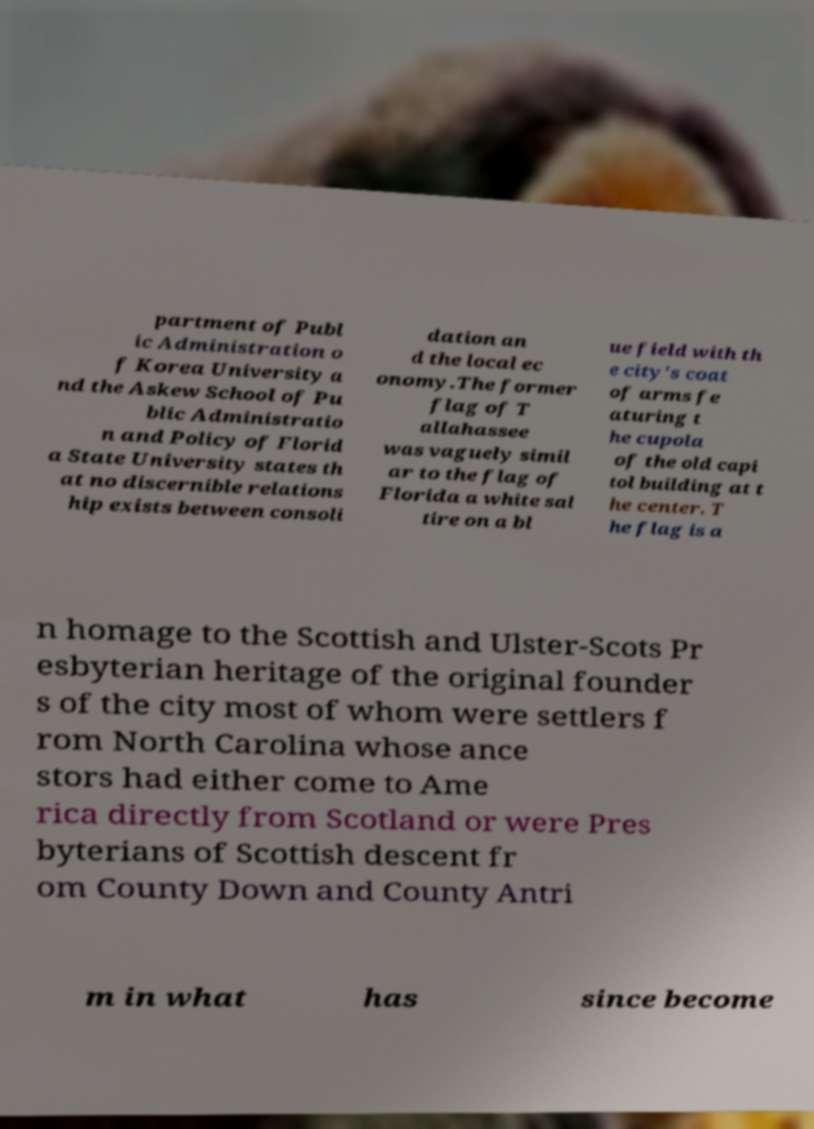Can you read and provide the text displayed in the image?This photo seems to have some interesting text. Can you extract and type it out for me? partment of Publ ic Administration o f Korea University a nd the Askew School of Pu blic Administratio n and Policy of Florid a State University states th at no discernible relations hip exists between consoli dation an d the local ec onomy.The former flag of T allahassee was vaguely simil ar to the flag of Florida a white sal tire on a bl ue field with th e city's coat of arms fe aturing t he cupola of the old capi tol building at t he center. T he flag is a n homage to the Scottish and Ulster-Scots Pr esbyterian heritage of the original founder s of the city most of whom were settlers f rom North Carolina whose ance stors had either come to Ame rica directly from Scotland or were Pres byterians of Scottish descent fr om County Down and County Antri m in what has since become 